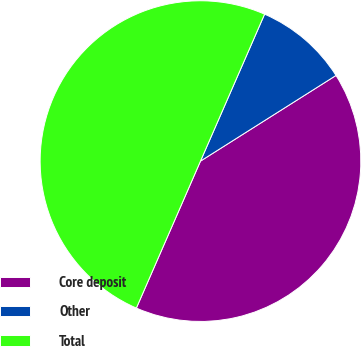Convert chart. <chart><loc_0><loc_0><loc_500><loc_500><pie_chart><fcel>Core deposit<fcel>Other<fcel>Total<nl><fcel>40.52%<fcel>9.48%<fcel>50.0%<nl></chart> 